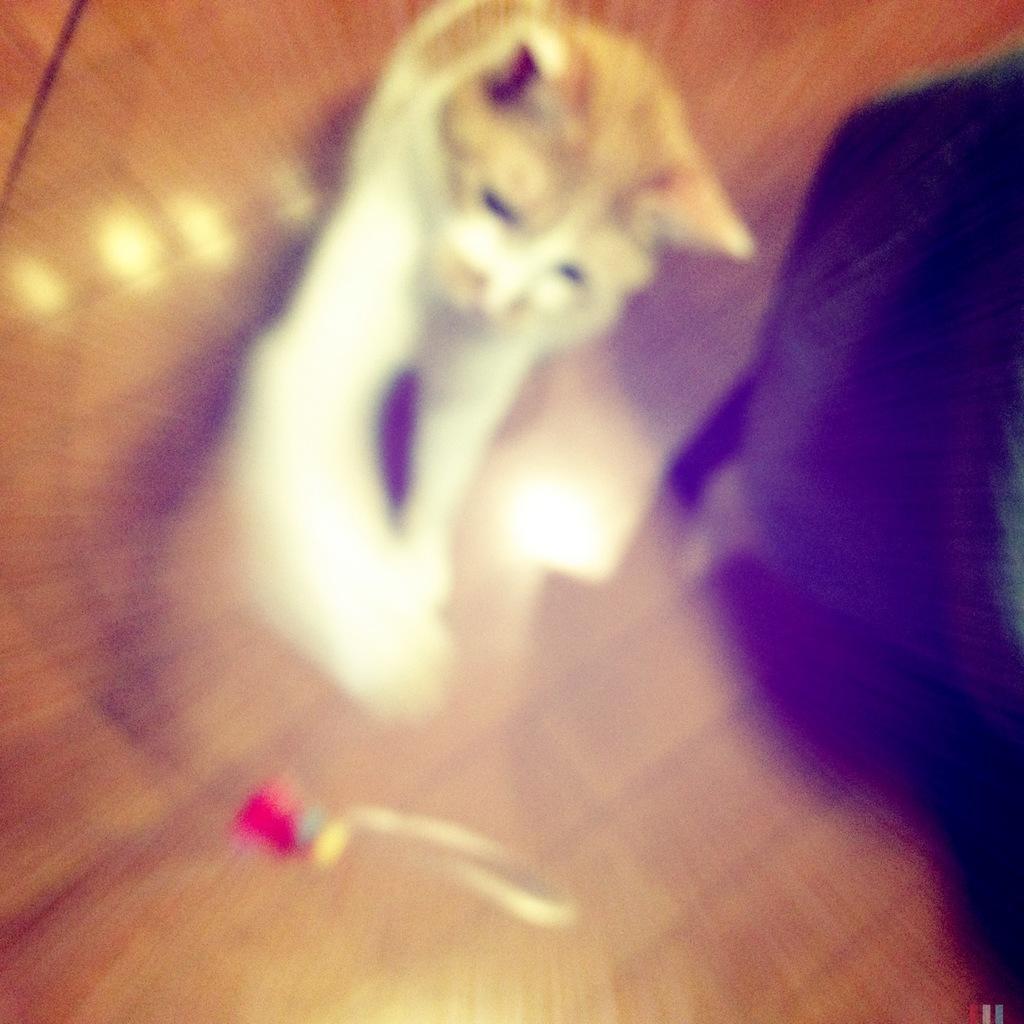Please provide a concise description of this image. In this image I can see a white color cat is under the table which is made up of a glass. On the right side, I can see a black color object. 